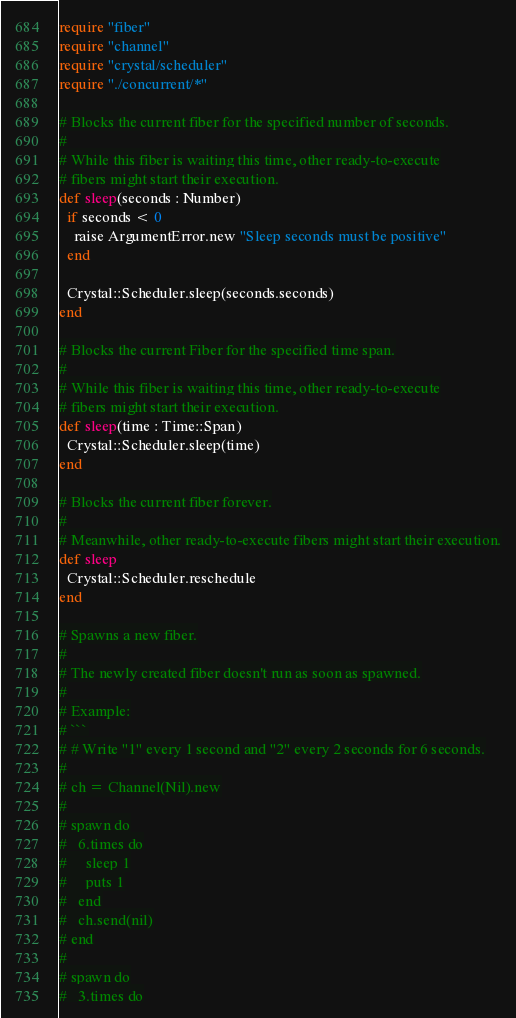<code> <loc_0><loc_0><loc_500><loc_500><_Crystal_>require "fiber"
require "channel"
require "crystal/scheduler"
require "./concurrent/*"

# Blocks the current fiber for the specified number of seconds.
#
# While this fiber is waiting this time, other ready-to-execute
# fibers might start their execution.
def sleep(seconds : Number)
  if seconds < 0
    raise ArgumentError.new "Sleep seconds must be positive"
  end

  Crystal::Scheduler.sleep(seconds.seconds)
end

# Blocks the current Fiber for the specified time span.
#
# While this fiber is waiting this time, other ready-to-execute
# fibers might start their execution.
def sleep(time : Time::Span)
  Crystal::Scheduler.sleep(time)
end

# Blocks the current fiber forever.
#
# Meanwhile, other ready-to-execute fibers might start their execution.
def sleep
  Crystal::Scheduler.reschedule
end

# Spawns a new fiber.
#
# The newly created fiber doesn't run as soon as spawned.
#
# Example:
# ```
# # Write "1" every 1 second and "2" every 2 seconds for 6 seconds.
#
# ch = Channel(Nil).new
#
# spawn do
#   6.times do
#     sleep 1
#     puts 1
#   end
#   ch.send(nil)
# end
#
# spawn do
#   3.times do</code> 